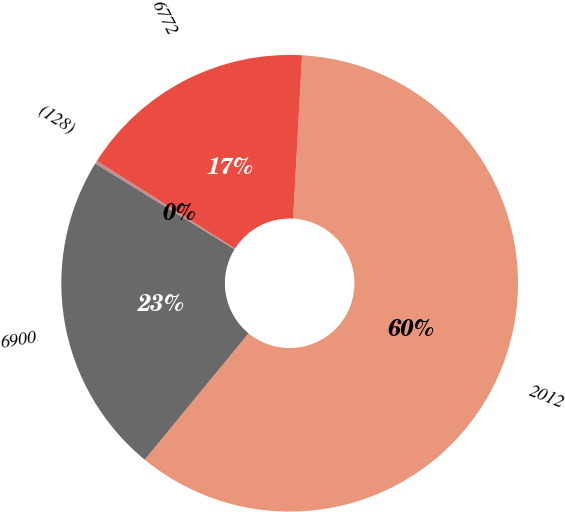Convert chart to OTSL. <chart><loc_0><loc_0><loc_500><loc_500><pie_chart><fcel>2012<fcel>6900<fcel>(128)<fcel>6772<nl><fcel>60.08%<fcel>22.85%<fcel>0.21%<fcel>16.86%<nl></chart> 